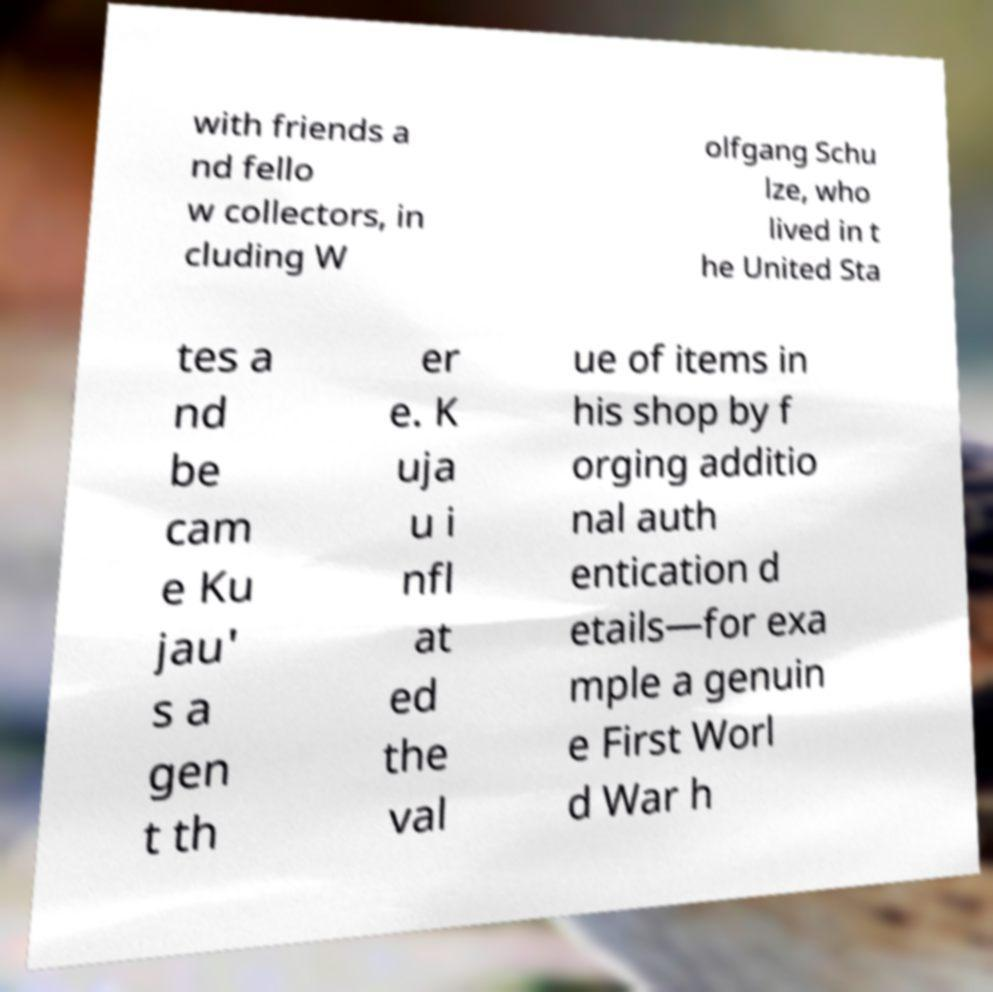There's text embedded in this image that I need extracted. Can you transcribe it verbatim? with friends a nd fello w collectors, in cluding W olfgang Schu lze, who lived in t he United Sta tes a nd be cam e Ku jau' s a gen t th er e. K uja u i nfl at ed the val ue of items in his shop by f orging additio nal auth entication d etails—for exa mple a genuin e First Worl d War h 